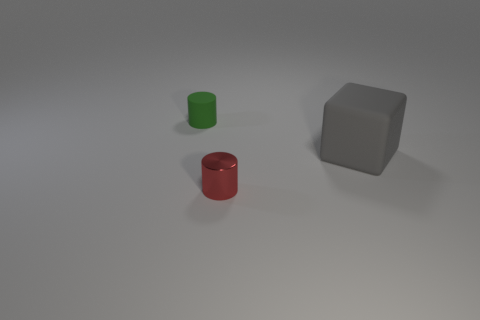Add 1 gray blocks. How many objects exist? 4 Subtract 2 cylinders. How many cylinders are left? 0 Subtract all green cylinders. How many cylinders are left? 1 Subtract all cylinders. How many objects are left? 1 Subtract 0 brown cylinders. How many objects are left? 3 Subtract all red blocks. Subtract all cyan cylinders. How many blocks are left? 1 Subtract all small matte objects. Subtract all yellow cylinders. How many objects are left? 2 Add 2 large gray rubber blocks. How many large gray rubber blocks are left? 3 Add 2 matte cylinders. How many matte cylinders exist? 3 